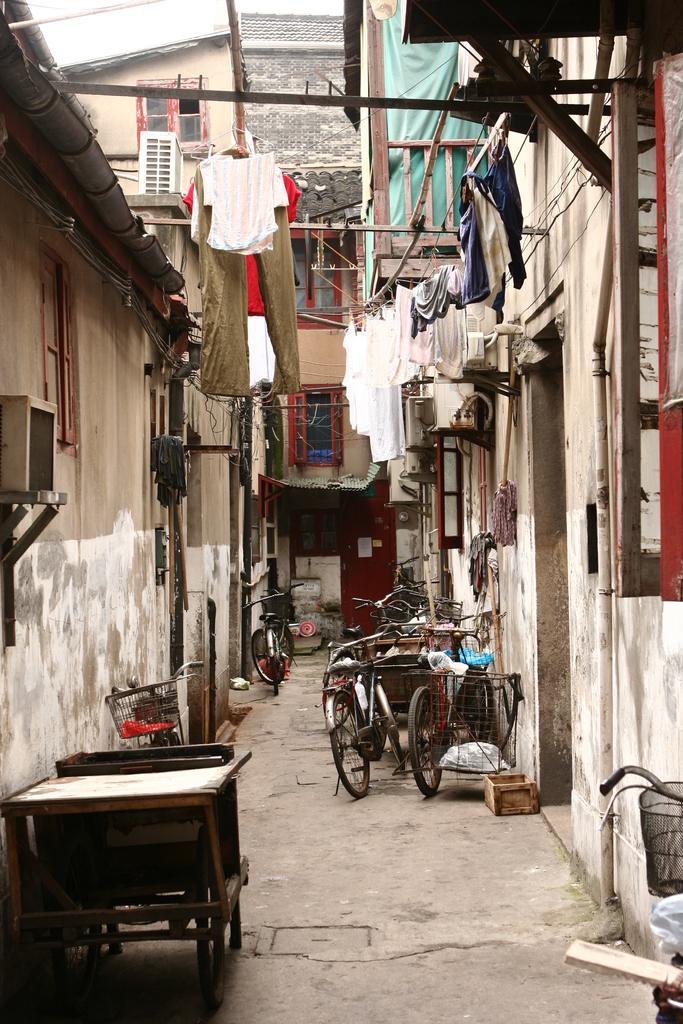Describe this image in one or two sentences. This image is clicked in a street. In the middle there are many cycles. On the left there is wall, cycle and window. On the right there is a building. 